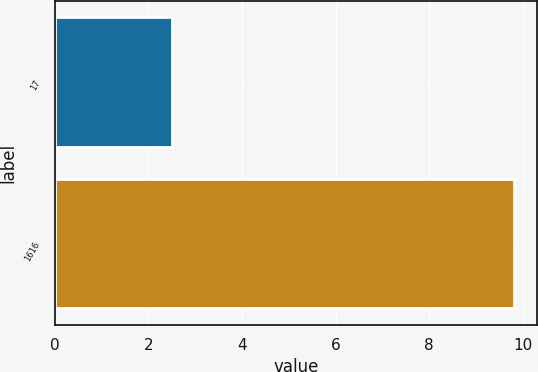<chart> <loc_0><loc_0><loc_500><loc_500><bar_chart><fcel>17<fcel>1616<nl><fcel>2.5<fcel>9.82<nl></chart> 